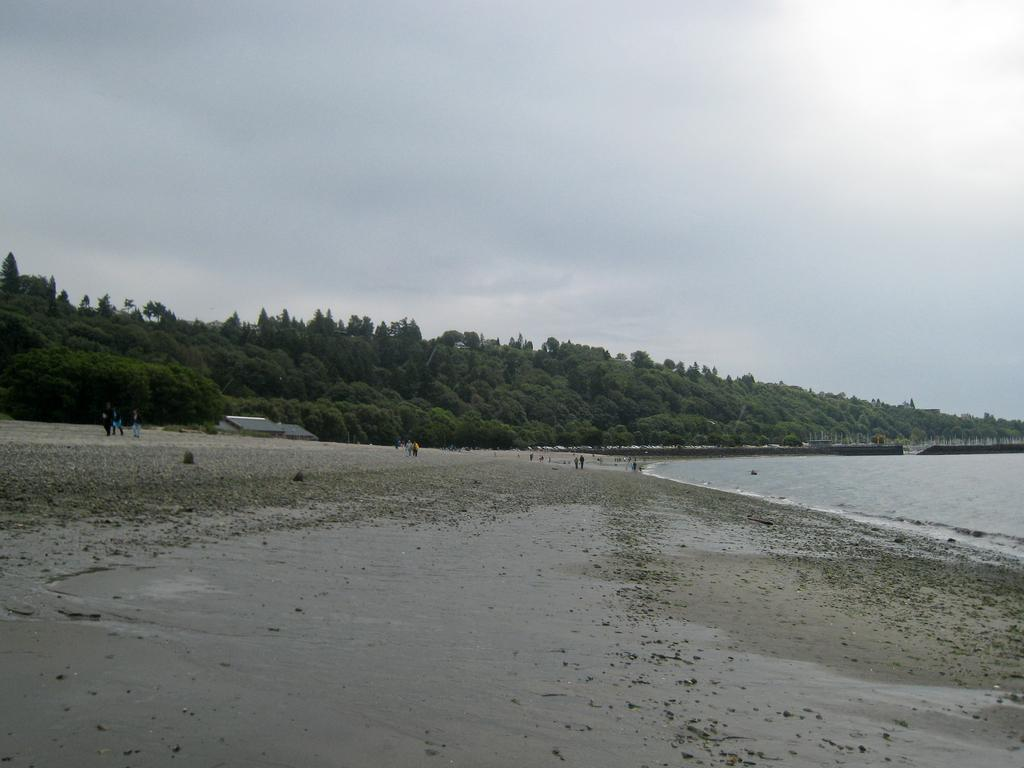What type of location is depicted in the front of the image? There is a beach in the front of the image. What are the people in the image doing? The people are walking in the back side of the image. What type of vegetation can be seen in the image? Trees are present in the image. What is visible in the sky in the image? The sky is visible in the image, and clouds are present in it. What type of badge is being worn by the trees in the image? There are no badges present in the image, as trees do not wear badges. What fact can be learned about the sponge in the image? There is no sponge present in the image, so no fact can be learned about it. 